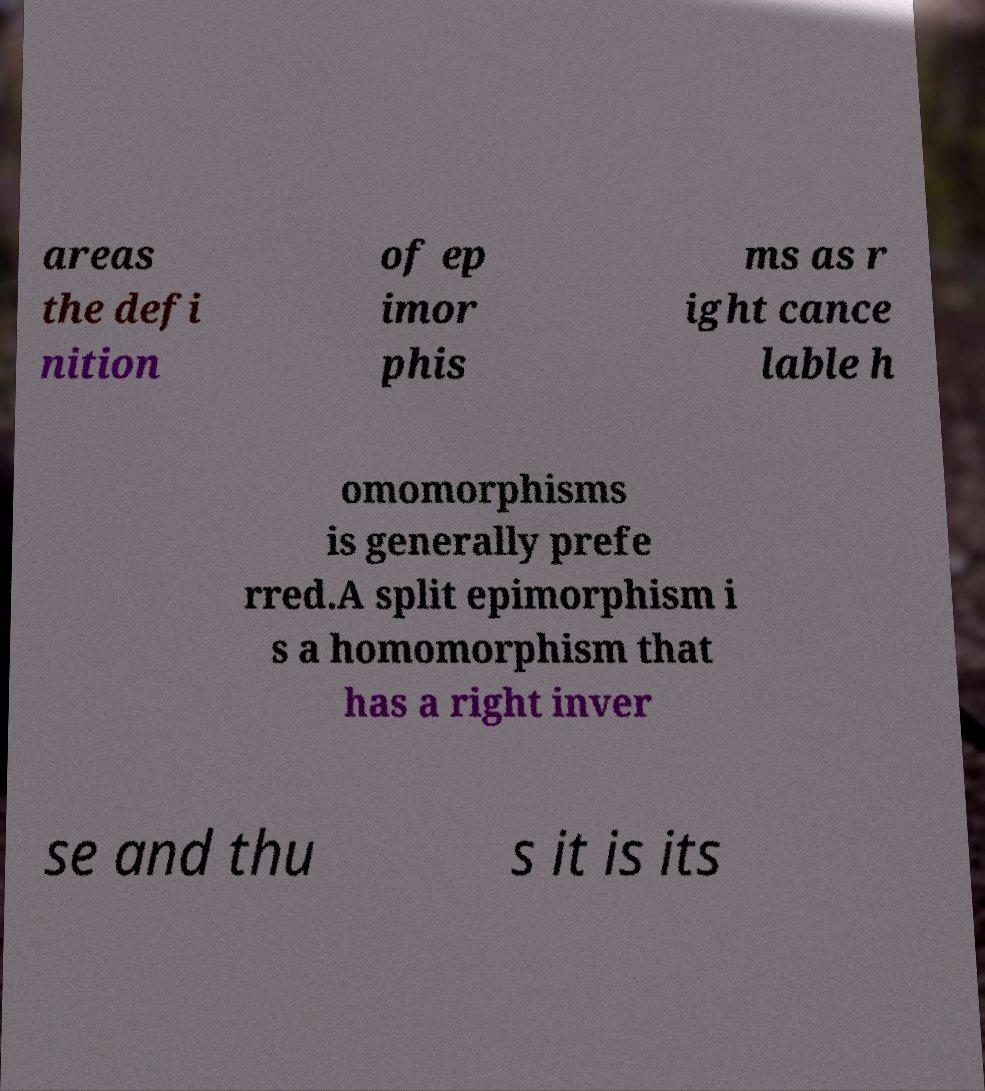Please identify and transcribe the text found in this image. areas the defi nition of ep imor phis ms as r ight cance lable h omomorphisms is generally prefe rred.A split epimorphism i s a homomorphism that has a right inver se and thu s it is its 